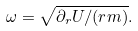<formula> <loc_0><loc_0><loc_500><loc_500>\omega = \sqrt { \partial _ { r } U / ( r m ) } .</formula> 